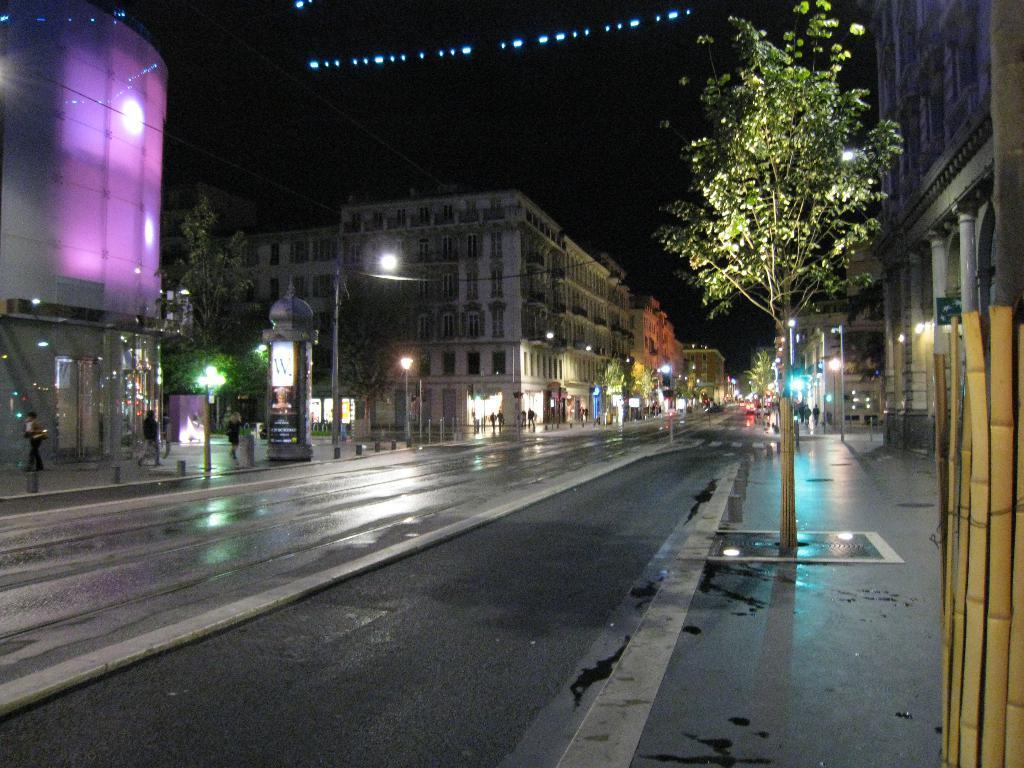Can you describe this image briefly? In this picture we can see the buildings, pillars, trees, lights, boards, poles and some persons. At the bottom of the image we can see the road. At the top of the image we can see the lights and sky. 